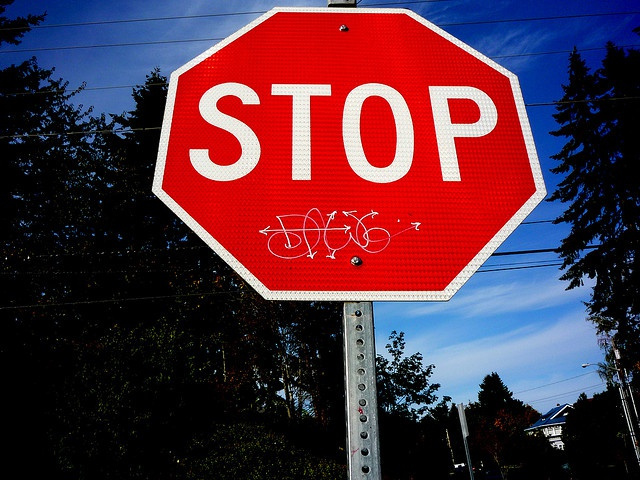Describe the objects in this image and their specific colors. I can see a stop sign in black, red, lightgray, brown, and lightpink tones in this image. 